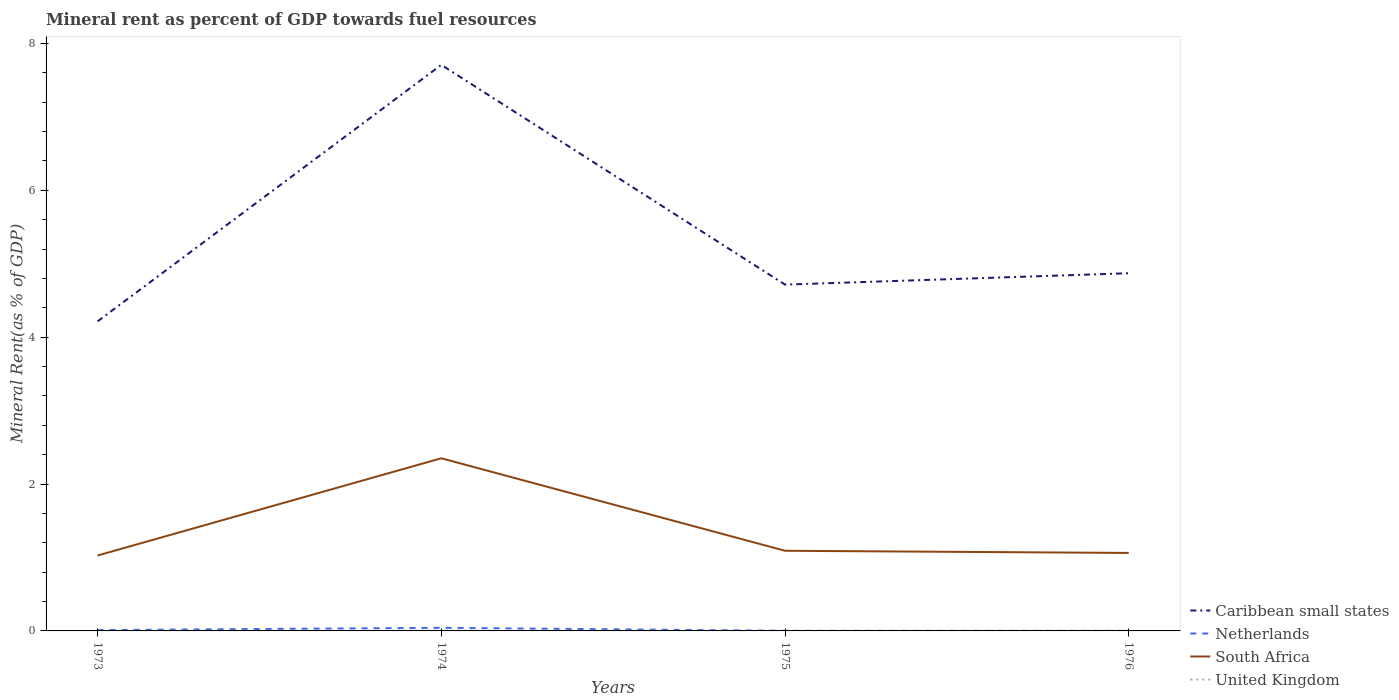How many different coloured lines are there?
Keep it short and to the point. 4. Does the line corresponding to South Africa intersect with the line corresponding to Caribbean small states?
Offer a terse response. No. Across all years, what is the maximum mineral rent in Netherlands?
Give a very brief answer. 0. In which year was the mineral rent in Netherlands maximum?
Your answer should be very brief. 1976. What is the total mineral rent in United Kingdom in the graph?
Provide a short and direct response. 0. What is the difference between the highest and the second highest mineral rent in South Africa?
Your response must be concise. 1.32. Is the mineral rent in Netherlands strictly greater than the mineral rent in South Africa over the years?
Offer a very short reply. Yes. How many years are there in the graph?
Your response must be concise. 4. What is the difference between two consecutive major ticks on the Y-axis?
Ensure brevity in your answer.  2. Are the values on the major ticks of Y-axis written in scientific E-notation?
Offer a terse response. No. How are the legend labels stacked?
Provide a short and direct response. Vertical. What is the title of the graph?
Offer a very short reply. Mineral rent as percent of GDP towards fuel resources. Does "Benin" appear as one of the legend labels in the graph?
Provide a short and direct response. No. What is the label or title of the Y-axis?
Your answer should be compact. Mineral Rent(as % of GDP). What is the Mineral Rent(as % of GDP) of Caribbean small states in 1973?
Your answer should be very brief. 4.22. What is the Mineral Rent(as % of GDP) of Netherlands in 1973?
Ensure brevity in your answer.  0.01. What is the Mineral Rent(as % of GDP) of South Africa in 1973?
Provide a short and direct response. 1.03. What is the Mineral Rent(as % of GDP) of United Kingdom in 1973?
Provide a succinct answer. 0. What is the Mineral Rent(as % of GDP) in Caribbean small states in 1974?
Provide a short and direct response. 7.71. What is the Mineral Rent(as % of GDP) of Netherlands in 1974?
Your answer should be very brief. 0.04. What is the Mineral Rent(as % of GDP) of South Africa in 1974?
Offer a terse response. 2.35. What is the Mineral Rent(as % of GDP) of United Kingdom in 1974?
Provide a short and direct response. 0. What is the Mineral Rent(as % of GDP) of Caribbean small states in 1975?
Keep it short and to the point. 4.72. What is the Mineral Rent(as % of GDP) of Netherlands in 1975?
Your answer should be very brief. 0. What is the Mineral Rent(as % of GDP) of South Africa in 1975?
Your answer should be very brief. 1.09. What is the Mineral Rent(as % of GDP) of United Kingdom in 1975?
Your response must be concise. 0. What is the Mineral Rent(as % of GDP) in Caribbean small states in 1976?
Offer a terse response. 4.87. What is the Mineral Rent(as % of GDP) of Netherlands in 1976?
Provide a short and direct response. 0. What is the Mineral Rent(as % of GDP) of South Africa in 1976?
Offer a very short reply. 1.06. What is the Mineral Rent(as % of GDP) of United Kingdom in 1976?
Your answer should be compact. 0. Across all years, what is the maximum Mineral Rent(as % of GDP) of Caribbean small states?
Your response must be concise. 7.71. Across all years, what is the maximum Mineral Rent(as % of GDP) of Netherlands?
Provide a short and direct response. 0.04. Across all years, what is the maximum Mineral Rent(as % of GDP) of South Africa?
Provide a succinct answer. 2.35. Across all years, what is the maximum Mineral Rent(as % of GDP) in United Kingdom?
Your answer should be compact. 0. Across all years, what is the minimum Mineral Rent(as % of GDP) in Caribbean small states?
Keep it short and to the point. 4.22. Across all years, what is the minimum Mineral Rent(as % of GDP) of Netherlands?
Ensure brevity in your answer.  0. Across all years, what is the minimum Mineral Rent(as % of GDP) in South Africa?
Provide a short and direct response. 1.03. Across all years, what is the minimum Mineral Rent(as % of GDP) in United Kingdom?
Your answer should be compact. 0. What is the total Mineral Rent(as % of GDP) of Caribbean small states in the graph?
Provide a short and direct response. 21.51. What is the total Mineral Rent(as % of GDP) in Netherlands in the graph?
Provide a short and direct response. 0.06. What is the total Mineral Rent(as % of GDP) of South Africa in the graph?
Provide a short and direct response. 5.53. What is the total Mineral Rent(as % of GDP) of United Kingdom in the graph?
Your answer should be compact. 0.01. What is the difference between the Mineral Rent(as % of GDP) of Caribbean small states in 1973 and that in 1974?
Make the answer very short. -3.49. What is the difference between the Mineral Rent(as % of GDP) of Netherlands in 1973 and that in 1974?
Offer a very short reply. -0.03. What is the difference between the Mineral Rent(as % of GDP) of South Africa in 1973 and that in 1974?
Your answer should be compact. -1.32. What is the difference between the Mineral Rent(as % of GDP) in United Kingdom in 1973 and that in 1974?
Provide a short and direct response. -0. What is the difference between the Mineral Rent(as % of GDP) of Caribbean small states in 1973 and that in 1975?
Offer a very short reply. -0.5. What is the difference between the Mineral Rent(as % of GDP) of Netherlands in 1973 and that in 1975?
Provide a succinct answer. 0.01. What is the difference between the Mineral Rent(as % of GDP) of South Africa in 1973 and that in 1975?
Provide a short and direct response. -0.06. What is the difference between the Mineral Rent(as % of GDP) of Caribbean small states in 1973 and that in 1976?
Ensure brevity in your answer.  -0.66. What is the difference between the Mineral Rent(as % of GDP) in Netherlands in 1973 and that in 1976?
Your response must be concise. 0.01. What is the difference between the Mineral Rent(as % of GDP) in South Africa in 1973 and that in 1976?
Keep it short and to the point. -0.04. What is the difference between the Mineral Rent(as % of GDP) of United Kingdom in 1973 and that in 1976?
Make the answer very short. -0. What is the difference between the Mineral Rent(as % of GDP) of Caribbean small states in 1974 and that in 1975?
Your answer should be compact. 2.99. What is the difference between the Mineral Rent(as % of GDP) of Netherlands in 1974 and that in 1975?
Give a very brief answer. 0.04. What is the difference between the Mineral Rent(as % of GDP) of South Africa in 1974 and that in 1975?
Provide a short and direct response. 1.26. What is the difference between the Mineral Rent(as % of GDP) in United Kingdom in 1974 and that in 1975?
Your answer should be compact. 0. What is the difference between the Mineral Rent(as % of GDP) in Caribbean small states in 1974 and that in 1976?
Your response must be concise. 2.84. What is the difference between the Mineral Rent(as % of GDP) in Netherlands in 1974 and that in 1976?
Offer a terse response. 0.04. What is the difference between the Mineral Rent(as % of GDP) in South Africa in 1974 and that in 1976?
Provide a short and direct response. 1.29. What is the difference between the Mineral Rent(as % of GDP) in United Kingdom in 1974 and that in 1976?
Give a very brief answer. 0. What is the difference between the Mineral Rent(as % of GDP) in Caribbean small states in 1975 and that in 1976?
Give a very brief answer. -0.15. What is the difference between the Mineral Rent(as % of GDP) in Netherlands in 1975 and that in 1976?
Your response must be concise. 0. What is the difference between the Mineral Rent(as % of GDP) in South Africa in 1975 and that in 1976?
Provide a short and direct response. 0.03. What is the difference between the Mineral Rent(as % of GDP) of United Kingdom in 1975 and that in 1976?
Provide a succinct answer. -0. What is the difference between the Mineral Rent(as % of GDP) of Caribbean small states in 1973 and the Mineral Rent(as % of GDP) of Netherlands in 1974?
Your answer should be compact. 4.17. What is the difference between the Mineral Rent(as % of GDP) of Caribbean small states in 1973 and the Mineral Rent(as % of GDP) of South Africa in 1974?
Offer a terse response. 1.86. What is the difference between the Mineral Rent(as % of GDP) in Caribbean small states in 1973 and the Mineral Rent(as % of GDP) in United Kingdom in 1974?
Your answer should be very brief. 4.21. What is the difference between the Mineral Rent(as % of GDP) of Netherlands in 1973 and the Mineral Rent(as % of GDP) of South Africa in 1974?
Your answer should be compact. -2.34. What is the difference between the Mineral Rent(as % of GDP) of Netherlands in 1973 and the Mineral Rent(as % of GDP) of United Kingdom in 1974?
Provide a short and direct response. 0.01. What is the difference between the Mineral Rent(as % of GDP) in South Africa in 1973 and the Mineral Rent(as % of GDP) in United Kingdom in 1974?
Keep it short and to the point. 1.02. What is the difference between the Mineral Rent(as % of GDP) of Caribbean small states in 1973 and the Mineral Rent(as % of GDP) of Netherlands in 1975?
Provide a succinct answer. 4.21. What is the difference between the Mineral Rent(as % of GDP) in Caribbean small states in 1973 and the Mineral Rent(as % of GDP) in South Africa in 1975?
Give a very brief answer. 3.12. What is the difference between the Mineral Rent(as % of GDP) of Caribbean small states in 1973 and the Mineral Rent(as % of GDP) of United Kingdom in 1975?
Provide a short and direct response. 4.22. What is the difference between the Mineral Rent(as % of GDP) in Netherlands in 1973 and the Mineral Rent(as % of GDP) in South Africa in 1975?
Offer a very short reply. -1.08. What is the difference between the Mineral Rent(as % of GDP) of Netherlands in 1973 and the Mineral Rent(as % of GDP) of United Kingdom in 1975?
Your answer should be very brief. 0.01. What is the difference between the Mineral Rent(as % of GDP) of South Africa in 1973 and the Mineral Rent(as % of GDP) of United Kingdom in 1975?
Ensure brevity in your answer.  1.03. What is the difference between the Mineral Rent(as % of GDP) of Caribbean small states in 1973 and the Mineral Rent(as % of GDP) of Netherlands in 1976?
Your answer should be very brief. 4.22. What is the difference between the Mineral Rent(as % of GDP) in Caribbean small states in 1973 and the Mineral Rent(as % of GDP) in South Africa in 1976?
Keep it short and to the point. 3.15. What is the difference between the Mineral Rent(as % of GDP) of Caribbean small states in 1973 and the Mineral Rent(as % of GDP) of United Kingdom in 1976?
Make the answer very short. 4.21. What is the difference between the Mineral Rent(as % of GDP) of Netherlands in 1973 and the Mineral Rent(as % of GDP) of South Africa in 1976?
Your answer should be compact. -1.05. What is the difference between the Mineral Rent(as % of GDP) in Netherlands in 1973 and the Mineral Rent(as % of GDP) in United Kingdom in 1976?
Offer a terse response. 0.01. What is the difference between the Mineral Rent(as % of GDP) of South Africa in 1973 and the Mineral Rent(as % of GDP) of United Kingdom in 1976?
Provide a succinct answer. 1.02. What is the difference between the Mineral Rent(as % of GDP) of Caribbean small states in 1974 and the Mineral Rent(as % of GDP) of Netherlands in 1975?
Provide a short and direct response. 7.71. What is the difference between the Mineral Rent(as % of GDP) in Caribbean small states in 1974 and the Mineral Rent(as % of GDP) in South Africa in 1975?
Ensure brevity in your answer.  6.62. What is the difference between the Mineral Rent(as % of GDP) of Caribbean small states in 1974 and the Mineral Rent(as % of GDP) of United Kingdom in 1975?
Your answer should be compact. 7.71. What is the difference between the Mineral Rent(as % of GDP) of Netherlands in 1974 and the Mineral Rent(as % of GDP) of South Africa in 1975?
Provide a short and direct response. -1.05. What is the difference between the Mineral Rent(as % of GDP) in Netherlands in 1974 and the Mineral Rent(as % of GDP) in United Kingdom in 1975?
Offer a terse response. 0.04. What is the difference between the Mineral Rent(as % of GDP) of South Africa in 1974 and the Mineral Rent(as % of GDP) of United Kingdom in 1975?
Make the answer very short. 2.35. What is the difference between the Mineral Rent(as % of GDP) in Caribbean small states in 1974 and the Mineral Rent(as % of GDP) in Netherlands in 1976?
Your response must be concise. 7.71. What is the difference between the Mineral Rent(as % of GDP) of Caribbean small states in 1974 and the Mineral Rent(as % of GDP) of South Africa in 1976?
Provide a short and direct response. 6.65. What is the difference between the Mineral Rent(as % of GDP) of Caribbean small states in 1974 and the Mineral Rent(as % of GDP) of United Kingdom in 1976?
Keep it short and to the point. 7.71. What is the difference between the Mineral Rent(as % of GDP) of Netherlands in 1974 and the Mineral Rent(as % of GDP) of South Africa in 1976?
Your answer should be compact. -1.02. What is the difference between the Mineral Rent(as % of GDP) of Netherlands in 1974 and the Mineral Rent(as % of GDP) of United Kingdom in 1976?
Give a very brief answer. 0.04. What is the difference between the Mineral Rent(as % of GDP) of South Africa in 1974 and the Mineral Rent(as % of GDP) of United Kingdom in 1976?
Keep it short and to the point. 2.35. What is the difference between the Mineral Rent(as % of GDP) of Caribbean small states in 1975 and the Mineral Rent(as % of GDP) of Netherlands in 1976?
Offer a terse response. 4.72. What is the difference between the Mineral Rent(as % of GDP) of Caribbean small states in 1975 and the Mineral Rent(as % of GDP) of South Africa in 1976?
Your response must be concise. 3.65. What is the difference between the Mineral Rent(as % of GDP) of Caribbean small states in 1975 and the Mineral Rent(as % of GDP) of United Kingdom in 1976?
Make the answer very short. 4.71. What is the difference between the Mineral Rent(as % of GDP) of Netherlands in 1975 and the Mineral Rent(as % of GDP) of South Africa in 1976?
Your response must be concise. -1.06. What is the difference between the Mineral Rent(as % of GDP) in Netherlands in 1975 and the Mineral Rent(as % of GDP) in United Kingdom in 1976?
Give a very brief answer. -0. What is the difference between the Mineral Rent(as % of GDP) of South Africa in 1975 and the Mineral Rent(as % of GDP) of United Kingdom in 1976?
Make the answer very short. 1.09. What is the average Mineral Rent(as % of GDP) in Caribbean small states per year?
Offer a terse response. 5.38. What is the average Mineral Rent(as % of GDP) of Netherlands per year?
Keep it short and to the point. 0.01. What is the average Mineral Rent(as % of GDP) of South Africa per year?
Offer a very short reply. 1.38. What is the average Mineral Rent(as % of GDP) in United Kingdom per year?
Your answer should be very brief. 0. In the year 1973, what is the difference between the Mineral Rent(as % of GDP) in Caribbean small states and Mineral Rent(as % of GDP) in Netherlands?
Give a very brief answer. 4.2. In the year 1973, what is the difference between the Mineral Rent(as % of GDP) of Caribbean small states and Mineral Rent(as % of GDP) of South Africa?
Make the answer very short. 3.19. In the year 1973, what is the difference between the Mineral Rent(as % of GDP) of Caribbean small states and Mineral Rent(as % of GDP) of United Kingdom?
Give a very brief answer. 4.21. In the year 1973, what is the difference between the Mineral Rent(as % of GDP) in Netherlands and Mineral Rent(as % of GDP) in South Africa?
Keep it short and to the point. -1.02. In the year 1973, what is the difference between the Mineral Rent(as % of GDP) of Netherlands and Mineral Rent(as % of GDP) of United Kingdom?
Provide a succinct answer. 0.01. In the year 1973, what is the difference between the Mineral Rent(as % of GDP) in South Africa and Mineral Rent(as % of GDP) in United Kingdom?
Make the answer very short. 1.03. In the year 1974, what is the difference between the Mineral Rent(as % of GDP) of Caribbean small states and Mineral Rent(as % of GDP) of Netherlands?
Offer a terse response. 7.67. In the year 1974, what is the difference between the Mineral Rent(as % of GDP) of Caribbean small states and Mineral Rent(as % of GDP) of South Africa?
Your answer should be compact. 5.36. In the year 1974, what is the difference between the Mineral Rent(as % of GDP) of Caribbean small states and Mineral Rent(as % of GDP) of United Kingdom?
Offer a very short reply. 7.7. In the year 1974, what is the difference between the Mineral Rent(as % of GDP) of Netherlands and Mineral Rent(as % of GDP) of South Africa?
Ensure brevity in your answer.  -2.31. In the year 1974, what is the difference between the Mineral Rent(as % of GDP) in Netherlands and Mineral Rent(as % of GDP) in United Kingdom?
Make the answer very short. 0.04. In the year 1974, what is the difference between the Mineral Rent(as % of GDP) of South Africa and Mineral Rent(as % of GDP) of United Kingdom?
Keep it short and to the point. 2.35. In the year 1975, what is the difference between the Mineral Rent(as % of GDP) in Caribbean small states and Mineral Rent(as % of GDP) in Netherlands?
Provide a succinct answer. 4.71. In the year 1975, what is the difference between the Mineral Rent(as % of GDP) in Caribbean small states and Mineral Rent(as % of GDP) in South Africa?
Your response must be concise. 3.62. In the year 1975, what is the difference between the Mineral Rent(as % of GDP) of Caribbean small states and Mineral Rent(as % of GDP) of United Kingdom?
Your response must be concise. 4.72. In the year 1975, what is the difference between the Mineral Rent(as % of GDP) of Netherlands and Mineral Rent(as % of GDP) of South Africa?
Offer a terse response. -1.09. In the year 1975, what is the difference between the Mineral Rent(as % of GDP) in Netherlands and Mineral Rent(as % of GDP) in United Kingdom?
Provide a short and direct response. 0. In the year 1975, what is the difference between the Mineral Rent(as % of GDP) of South Africa and Mineral Rent(as % of GDP) of United Kingdom?
Keep it short and to the point. 1.09. In the year 1976, what is the difference between the Mineral Rent(as % of GDP) in Caribbean small states and Mineral Rent(as % of GDP) in Netherlands?
Your answer should be very brief. 4.87. In the year 1976, what is the difference between the Mineral Rent(as % of GDP) in Caribbean small states and Mineral Rent(as % of GDP) in South Africa?
Offer a terse response. 3.81. In the year 1976, what is the difference between the Mineral Rent(as % of GDP) in Caribbean small states and Mineral Rent(as % of GDP) in United Kingdom?
Give a very brief answer. 4.87. In the year 1976, what is the difference between the Mineral Rent(as % of GDP) in Netherlands and Mineral Rent(as % of GDP) in South Africa?
Your response must be concise. -1.06. In the year 1976, what is the difference between the Mineral Rent(as % of GDP) of Netherlands and Mineral Rent(as % of GDP) of United Kingdom?
Provide a succinct answer. -0. In the year 1976, what is the difference between the Mineral Rent(as % of GDP) in South Africa and Mineral Rent(as % of GDP) in United Kingdom?
Give a very brief answer. 1.06. What is the ratio of the Mineral Rent(as % of GDP) in Caribbean small states in 1973 to that in 1974?
Your answer should be very brief. 0.55. What is the ratio of the Mineral Rent(as % of GDP) of Netherlands in 1973 to that in 1974?
Keep it short and to the point. 0.27. What is the ratio of the Mineral Rent(as % of GDP) of South Africa in 1973 to that in 1974?
Give a very brief answer. 0.44. What is the ratio of the Mineral Rent(as % of GDP) in United Kingdom in 1973 to that in 1974?
Your response must be concise. 0.16. What is the ratio of the Mineral Rent(as % of GDP) in Caribbean small states in 1973 to that in 1975?
Make the answer very short. 0.89. What is the ratio of the Mineral Rent(as % of GDP) of Netherlands in 1973 to that in 1975?
Your answer should be very brief. 5.97. What is the ratio of the Mineral Rent(as % of GDP) in South Africa in 1973 to that in 1975?
Provide a short and direct response. 0.94. What is the ratio of the Mineral Rent(as % of GDP) of United Kingdom in 1973 to that in 1975?
Provide a short and direct response. 1.7. What is the ratio of the Mineral Rent(as % of GDP) in Caribbean small states in 1973 to that in 1976?
Ensure brevity in your answer.  0.87. What is the ratio of the Mineral Rent(as % of GDP) of Netherlands in 1973 to that in 1976?
Your answer should be very brief. 21.57. What is the ratio of the Mineral Rent(as % of GDP) of South Africa in 1973 to that in 1976?
Your answer should be very brief. 0.97. What is the ratio of the Mineral Rent(as % of GDP) of United Kingdom in 1973 to that in 1976?
Ensure brevity in your answer.  0.24. What is the ratio of the Mineral Rent(as % of GDP) in Caribbean small states in 1974 to that in 1975?
Your answer should be very brief. 1.63. What is the ratio of the Mineral Rent(as % of GDP) of Netherlands in 1974 to that in 1975?
Provide a succinct answer. 22.01. What is the ratio of the Mineral Rent(as % of GDP) of South Africa in 1974 to that in 1975?
Your answer should be very brief. 2.15. What is the ratio of the Mineral Rent(as % of GDP) in United Kingdom in 1974 to that in 1975?
Your answer should be very brief. 10.89. What is the ratio of the Mineral Rent(as % of GDP) in Caribbean small states in 1974 to that in 1976?
Make the answer very short. 1.58. What is the ratio of the Mineral Rent(as % of GDP) of Netherlands in 1974 to that in 1976?
Keep it short and to the point. 79.49. What is the ratio of the Mineral Rent(as % of GDP) in South Africa in 1974 to that in 1976?
Ensure brevity in your answer.  2.21. What is the ratio of the Mineral Rent(as % of GDP) of United Kingdom in 1974 to that in 1976?
Give a very brief answer. 1.52. What is the ratio of the Mineral Rent(as % of GDP) of Caribbean small states in 1975 to that in 1976?
Your answer should be compact. 0.97. What is the ratio of the Mineral Rent(as % of GDP) of Netherlands in 1975 to that in 1976?
Keep it short and to the point. 3.61. What is the ratio of the Mineral Rent(as % of GDP) of South Africa in 1975 to that in 1976?
Offer a terse response. 1.03. What is the ratio of the Mineral Rent(as % of GDP) in United Kingdom in 1975 to that in 1976?
Provide a succinct answer. 0.14. What is the difference between the highest and the second highest Mineral Rent(as % of GDP) in Caribbean small states?
Provide a succinct answer. 2.84. What is the difference between the highest and the second highest Mineral Rent(as % of GDP) of Netherlands?
Your answer should be compact. 0.03. What is the difference between the highest and the second highest Mineral Rent(as % of GDP) of South Africa?
Your answer should be very brief. 1.26. What is the difference between the highest and the second highest Mineral Rent(as % of GDP) in United Kingdom?
Give a very brief answer. 0. What is the difference between the highest and the lowest Mineral Rent(as % of GDP) of Caribbean small states?
Provide a short and direct response. 3.49. What is the difference between the highest and the lowest Mineral Rent(as % of GDP) of Netherlands?
Provide a short and direct response. 0.04. What is the difference between the highest and the lowest Mineral Rent(as % of GDP) in South Africa?
Keep it short and to the point. 1.32. What is the difference between the highest and the lowest Mineral Rent(as % of GDP) in United Kingdom?
Provide a succinct answer. 0. 